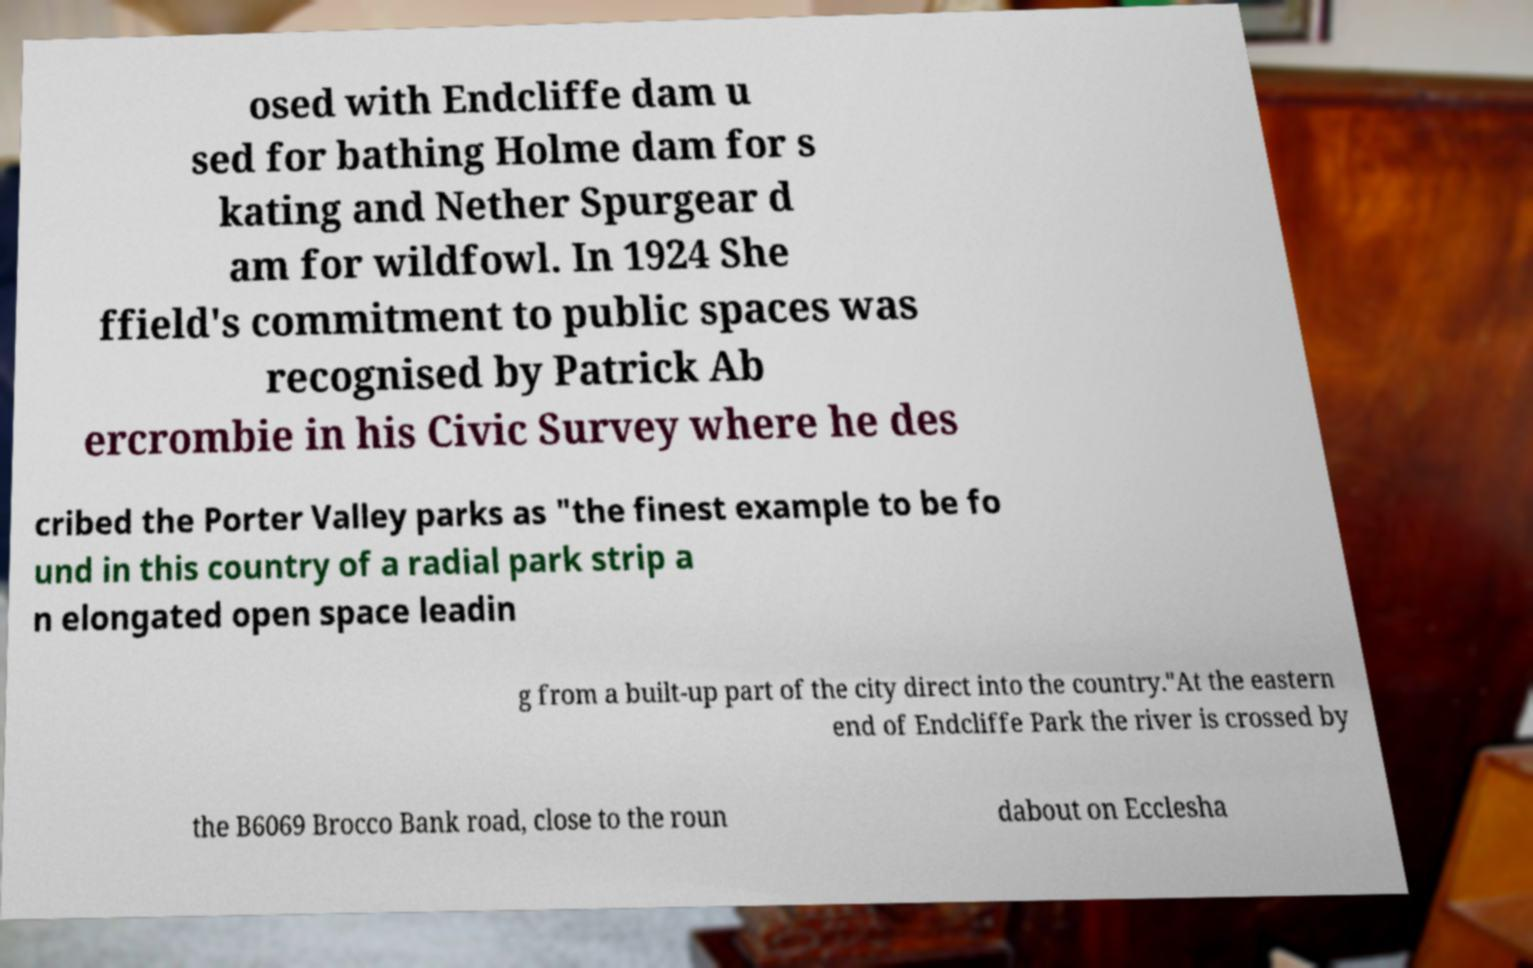Could you assist in decoding the text presented in this image and type it out clearly? osed with Endcliffe dam u sed for bathing Holme dam for s kating and Nether Spurgear d am for wildfowl. In 1924 She ffield's commitment to public spaces was recognised by Patrick Ab ercrombie in his Civic Survey where he des cribed the Porter Valley parks as "the finest example to be fo und in this country of a radial park strip a n elongated open space leadin g from a built-up part of the city direct into the country."At the eastern end of Endcliffe Park the river is crossed by the B6069 Brocco Bank road, close to the roun dabout on Ecclesha 